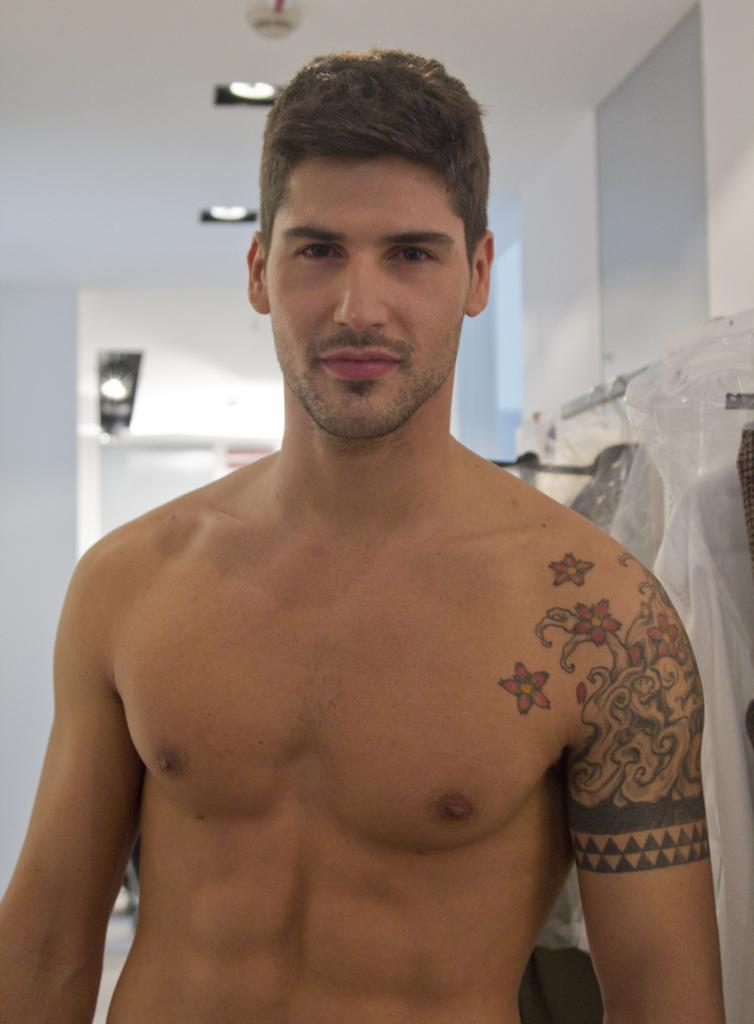Who is the main subject in the image? There is a man in the image. What is the man doing in the image? The man is watching. Can you describe any distinguishing features of the man? The man has a tattoo on his arm. What can be seen in the background of the image? There is a wall, objects, a cover, a ceiling, and lights in the background of the image. What is the name of the man's mom in the image? There is no information about the man's mom in the image, so we cannot determine her name. What type of engine is powering the man's car in the image? There is no car or engine present in the image. 